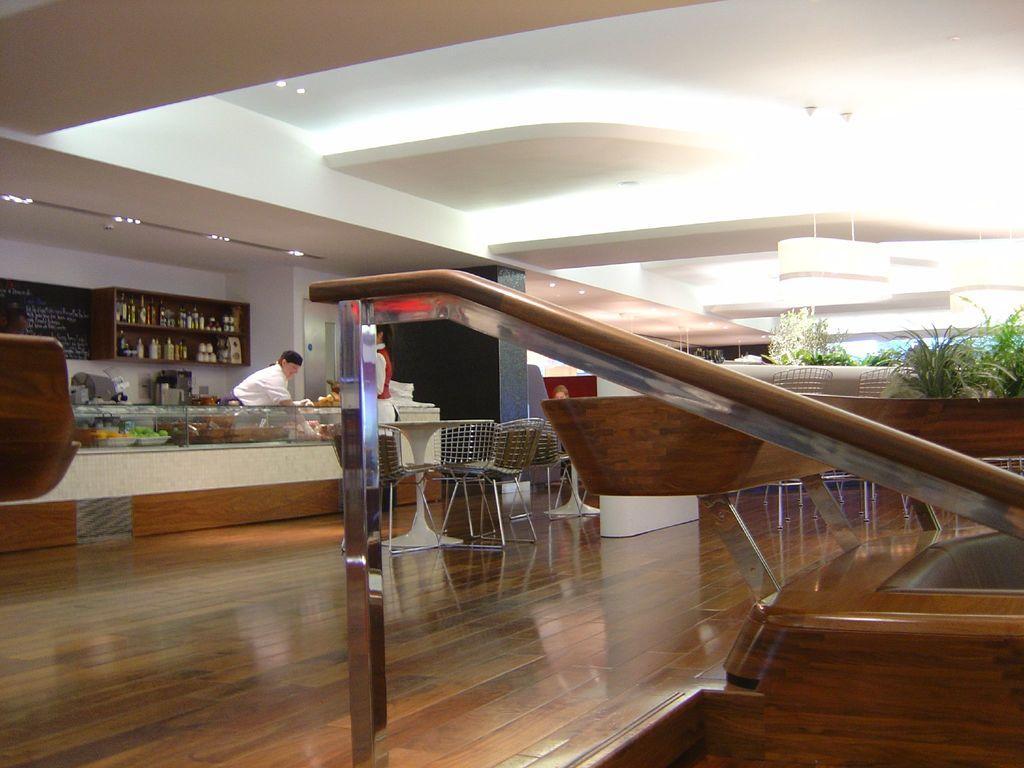Can you describe this image briefly? In this picture we can see chairs, plants, lights, table, bottles in racks, trays, poster on the wall and some objects and in the background we can see three people and a person standing. 